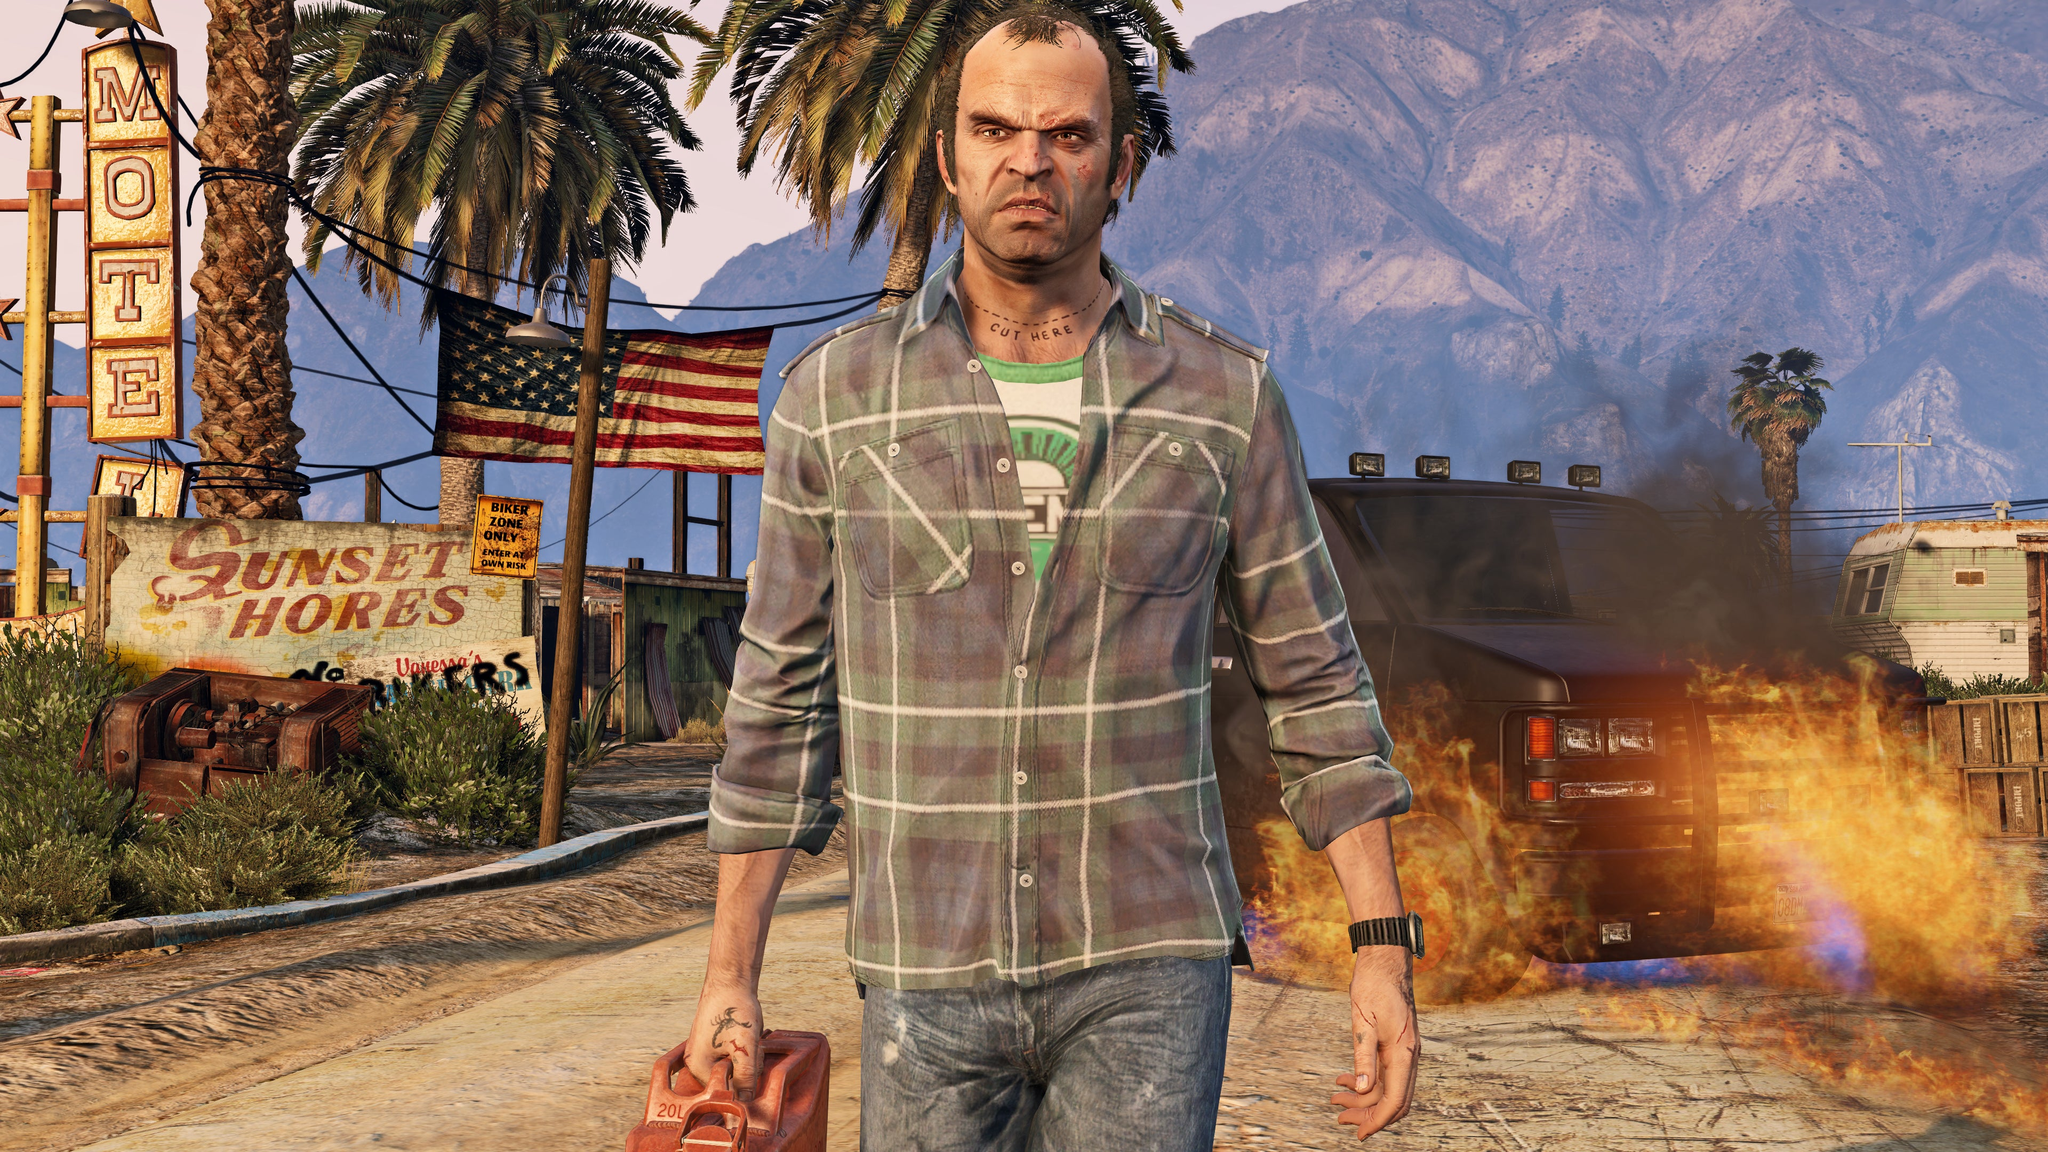Considering the condition of the motel sign, what might this imply about the economic state of the area? The weathered and neglected condition of the motel sign implies that the area might be experiencing economic difficulties. The faded paint, rust, and overall disrepair of the sign suggest a lack of investment in maintenance. This deterioration could be due to local economic hardships, a decline in business, or a decrease in tourism. Combined with other elements like the rundown surroundings and an unsupervised fire, this paints a picture of an area that has likely seen better days and reflects ongoing economic challenges. 